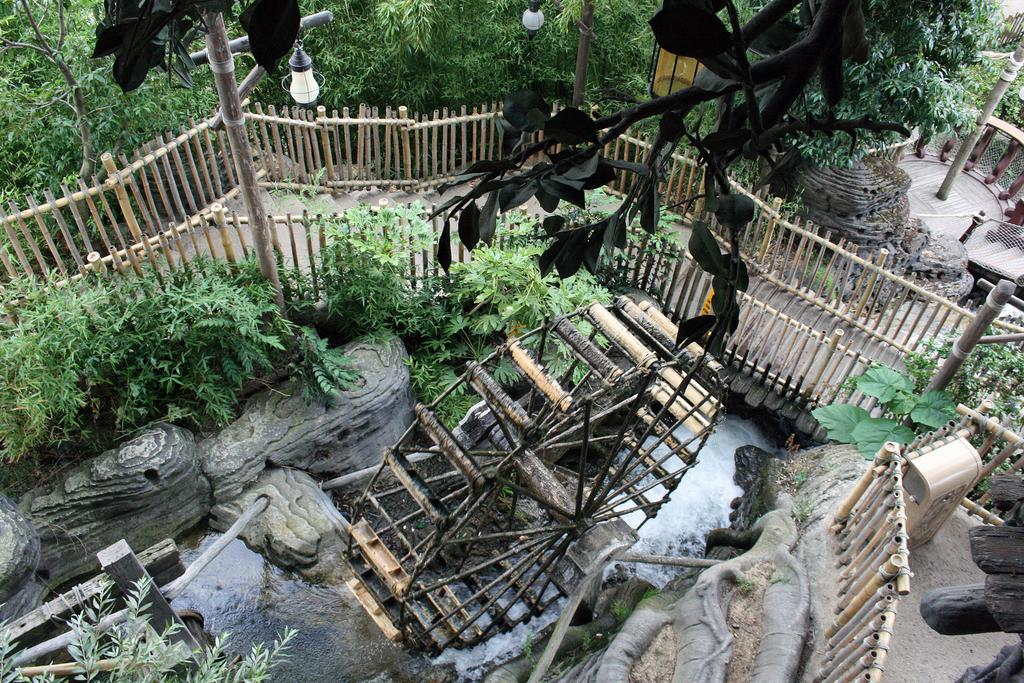What type of natural scenery can be seen in the background of the image? There are trees in the background of the image. What type of structure is present in the image? There is a fencing in the image. What is the main object in the center of the image? There is a wooden object in the center of the image. What can be seen besides the trees and fencing in the image? There is water visible in the image. What type of beetle can be seen crawling on the wooden object in the image? There is no beetle present in the image; it only features trees, fencing, a wooden object, and water. What appliance is being used to clean the water in the image? There is no appliance present in the image; it only features trees, fencing, a wooden object, and water. 